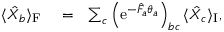<formula> <loc_0><loc_0><loc_500><loc_500>\begin{array} { r l r } { \langle \hat { X } _ { b } \rangle _ { F } } & = } & { \sum _ { c } \left ( e ^ { - \hat { F } _ { a } \theta _ { a } } \right ) _ { b c } \langle \hat { X } _ { c } \rangle _ { I } , } \end{array}</formula> 